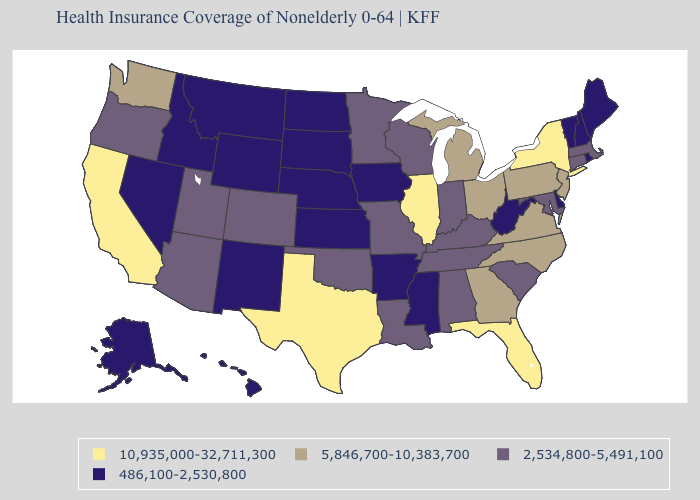What is the highest value in the MidWest ?
Short answer required. 10,935,000-32,711,300. What is the lowest value in states that border Missouri?
Quick response, please. 486,100-2,530,800. What is the value of North Carolina?
Short answer required. 5,846,700-10,383,700. Which states hav the highest value in the Northeast?
Give a very brief answer. New York. How many symbols are there in the legend?
Give a very brief answer. 4. What is the value of New Hampshire?
Be succinct. 486,100-2,530,800. What is the value of Maryland?
Short answer required. 2,534,800-5,491,100. What is the value of Louisiana?
Keep it brief. 2,534,800-5,491,100. Name the states that have a value in the range 2,534,800-5,491,100?
Concise answer only. Alabama, Arizona, Colorado, Connecticut, Indiana, Kentucky, Louisiana, Maryland, Massachusetts, Minnesota, Missouri, Oklahoma, Oregon, South Carolina, Tennessee, Utah, Wisconsin. What is the value of Wisconsin?
Concise answer only. 2,534,800-5,491,100. Does California have a higher value than Illinois?
Answer briefly. No. What is the highest value in the USA?
Give a very brief answer. 10,935,000-32,711,300. What is the value of Louisiana?
Keep it brief. 2,534,800-5,491,100. Does the first symbol in the legend represent the smallest category?
Concise answer only. No. What is the value of Rhode Island?
Keep it brief. 486,100-2,530,800. 